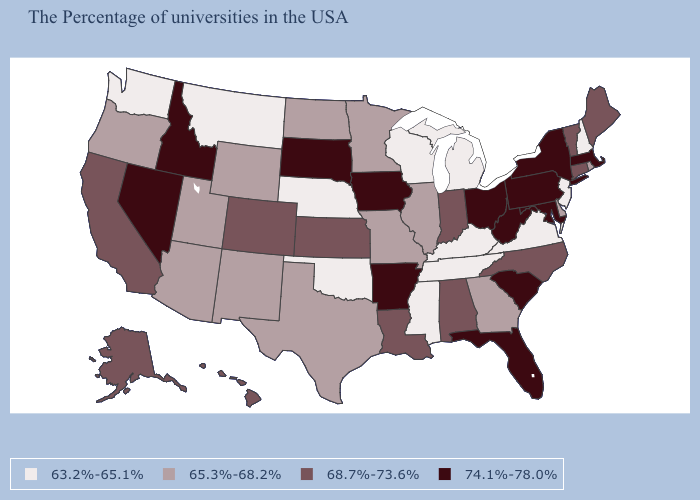Does Texas have a lower value than North Carolina?
Answer briefly. Yes. Does Alaska have a higher value than South Dakota?
Be succinct. No. Name the states that have a value in the range 63.2%-65.1%?
Concise answer only. New Hampshire, New Jersey, Virginia, Michigan, Kentucky, Tennessee, Wisconsin, Mississippi, Nebraska, Oklahoma, Montana, Washington. What is the value of New York?
Be succinct. 74.1%-78.0%. Name the states that have a value in the range 74.1%-78.0%?
Keep it brief. Massachusetts, New York, Maryland, Pennsylvania, South Carolina, West Virginia, Ohio, Florida, Arkansas, Iowa, South Dakota, Idaho, Nevada. What is the lowest value in states that border Montana?
Write a very short answer. 65.3%-68.2%. What is the value of Arkansas?
Keep it brief. 74.1%-78.0%. What is the highest value in states that border Mississippi?
Be succinct. 74.1%-78.0%. How many symbols are there in the legend?
Answer briefly. 4. Name the states that have a value in the range 65.3%-68.2%?
Give a very brief answer. Rhode Island, Delaware, Georgia, Illinois, Missouri, Minnesota, Texas, North Dakota, Wyoming, New Mexico, Utah, Arizona, Oregon. Name the states that have a value in the range 63.2%-65.1%?
Keep it brief. New Hampshire, New Jersey, Virginia, Michigan, Kentucky, Tennessee, Wisconsin, Mississippi, Nebraska, Oklahoma, Montana, Washington. Name the states that have a value in the range 74.1%-78.0%?
Write a very short answer. Massachusetts, New York, Maryland, Pennsylvania, South Carolina, West Virginia, Ohio, Florida, Arkansas, Iowa, South Dakota, Idaho, Nevada. Name the states that have a value in the range 68.7%-73.6%?
Quick response, please. Maine, Vermont, Connecticut, North Carolina, Indiana, Alabama, Louisiana, Kansas, Colorado, California, Alaska, Hawaii. Name the states that have a value in the range 68.7%-73.6%?
Give a very brief answer. Maine, Vermont, Connecticut, North Carolina, Indiana, Alabama, Louisiana, Kansas, Colorado, California, Alaska, Hawaii. Does the first symbol in the legend represent the smallest category?
Concise answer only. Yes. 